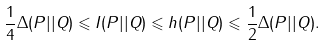<formula> <loc_0><loc_0><loc_500><loc_500>\frac { 1 } { 4 } \Delta ( P | | Q ) \leqslant I ( P | | Q ) \leqslant h ( P | | Q ) \leqslant \frac { 1 } { 2 } \Delta ( P | | Q ) .</formula> 